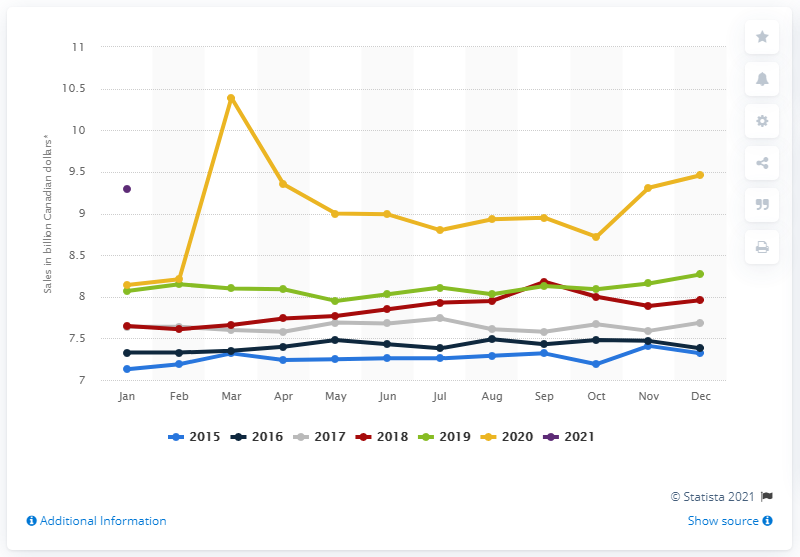Is the data in this chart inflation-adjusted? The chart does not specify whether the data is inflation-adjusted. For a precise analysis of real growth or decline in sales, we would need to consider inflation rates for the corresponding years to understand the actual purchasing power represented by these figures. 